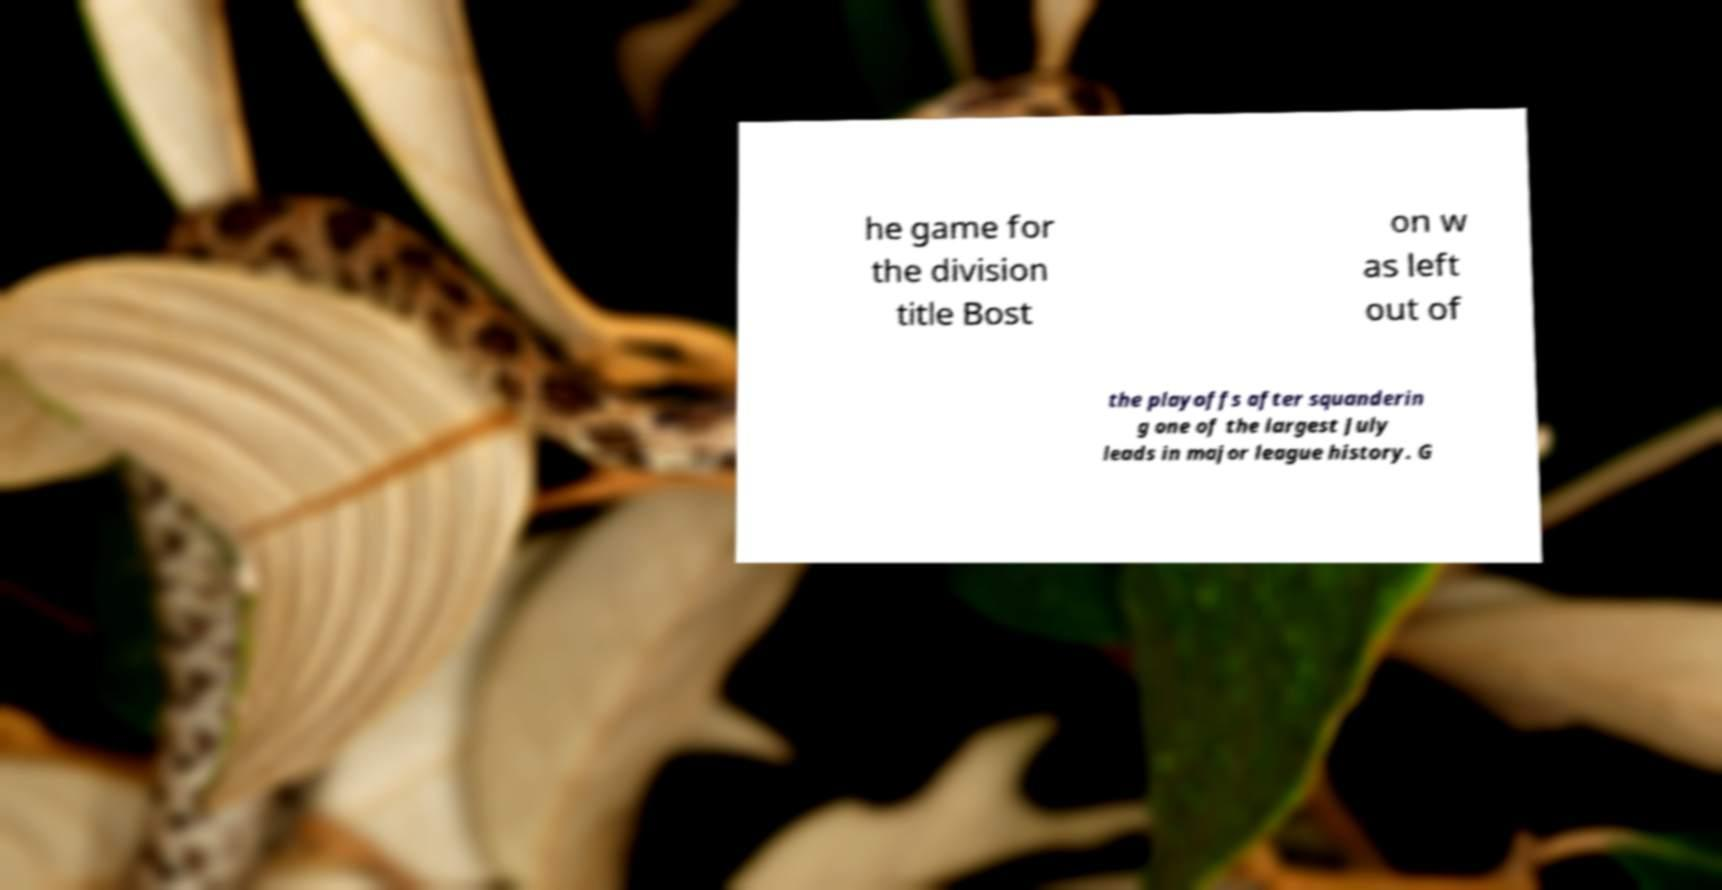Could you assist in decoding the text presented in this image and type it out clearly? he game for the division title Bost on w as left out of the playoffs after squanderin g one of the largest July leads in major league history. G 